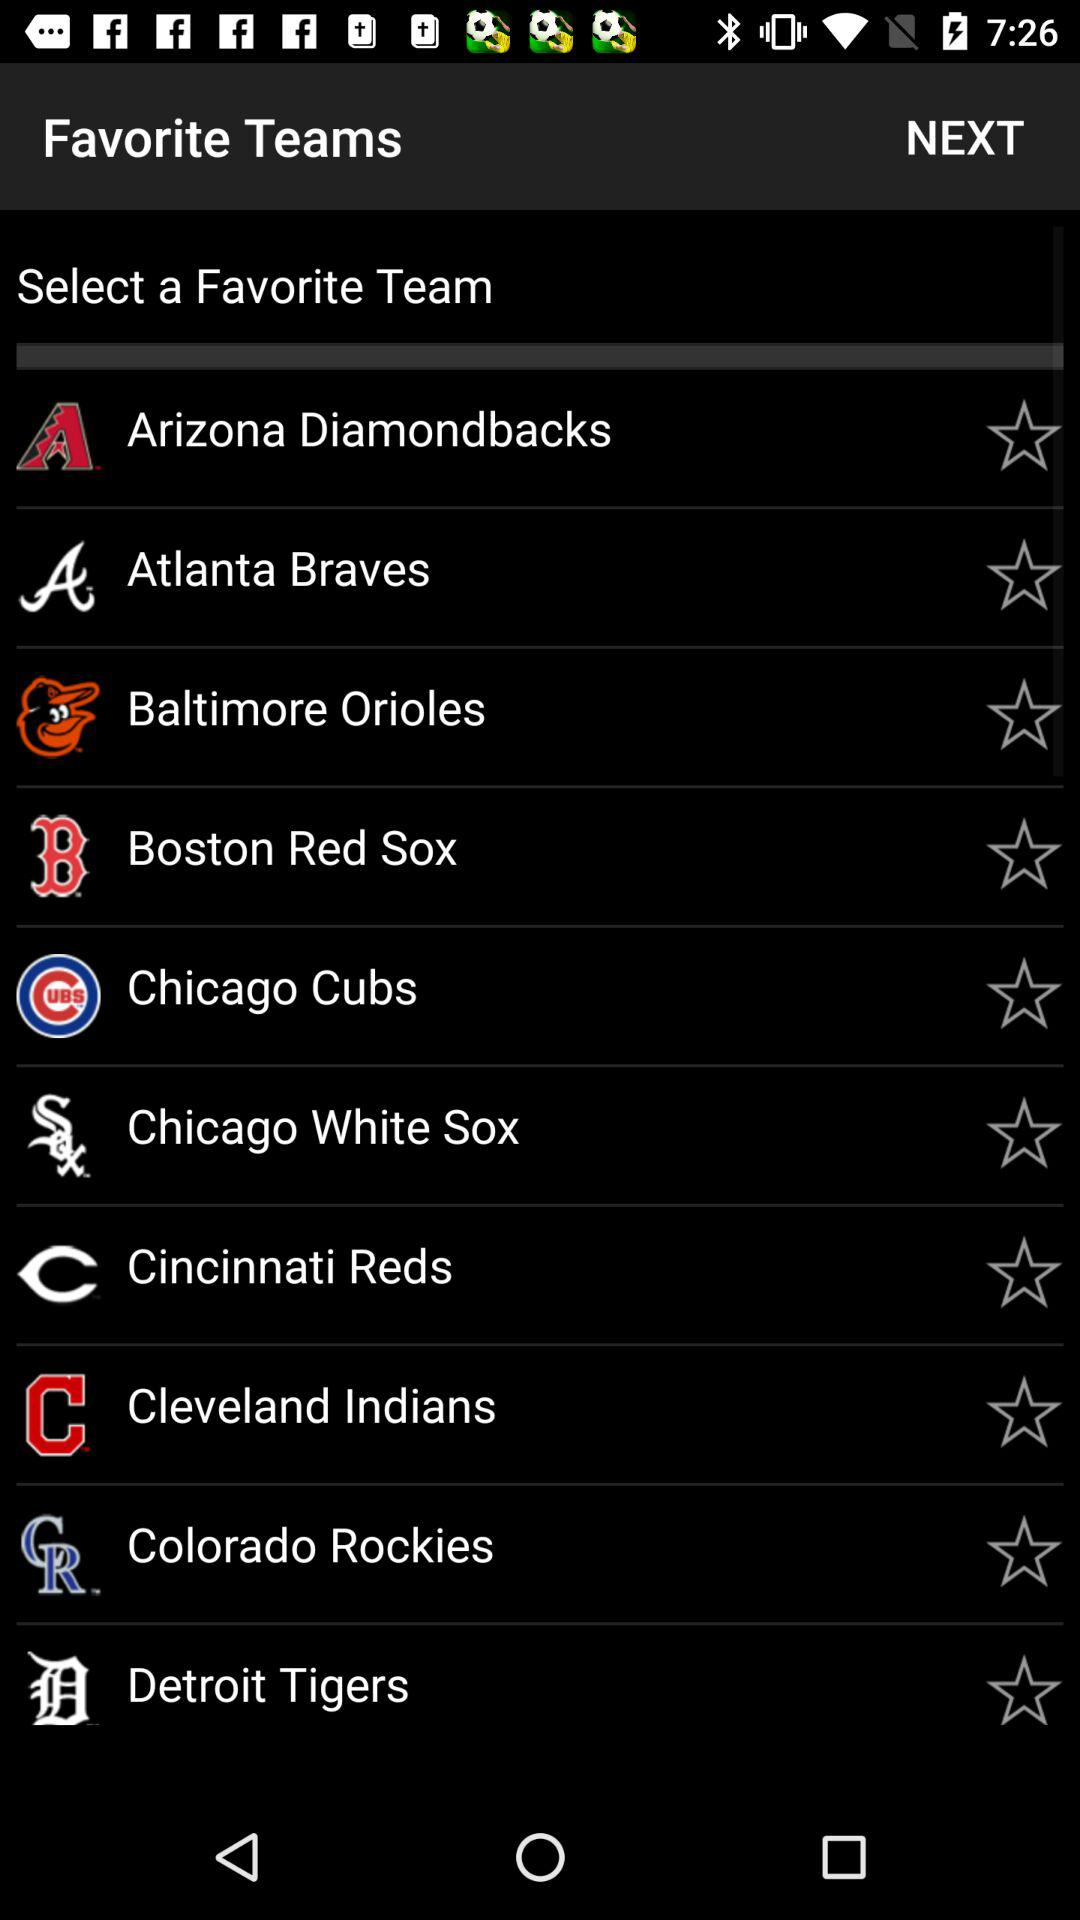What are the available options? The available options are "Arizona Diamondbacks", "Atlanta Braves", "Baltimore Orioles", "Boston Red Sox", "Chicago Cubs", "Chicago White Sox", "Cincinnati Reds", "Cleveland Indians", "Colorado Rockies" and "Detroit Tigers". 